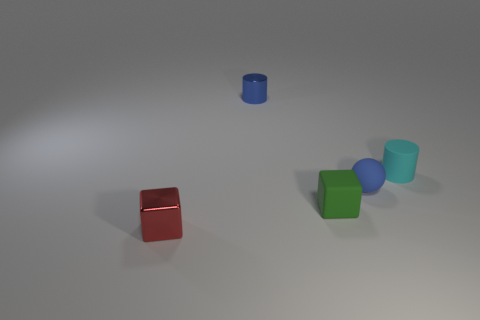Add 5 tiny blue matte spheres. How many objects exist? 10 Subtract all balls. How many objects are left? 4 Add 5 small green matte cubes. How many small green matte cubes are left? 6 Add 1 red metal cubes. How many red metal cubes exist? 2 Subtract 0 green cylinders. How many objects are left? 5 Subtract all tiny green objects. Subtract all metal blocks. How many objects are left? 3 